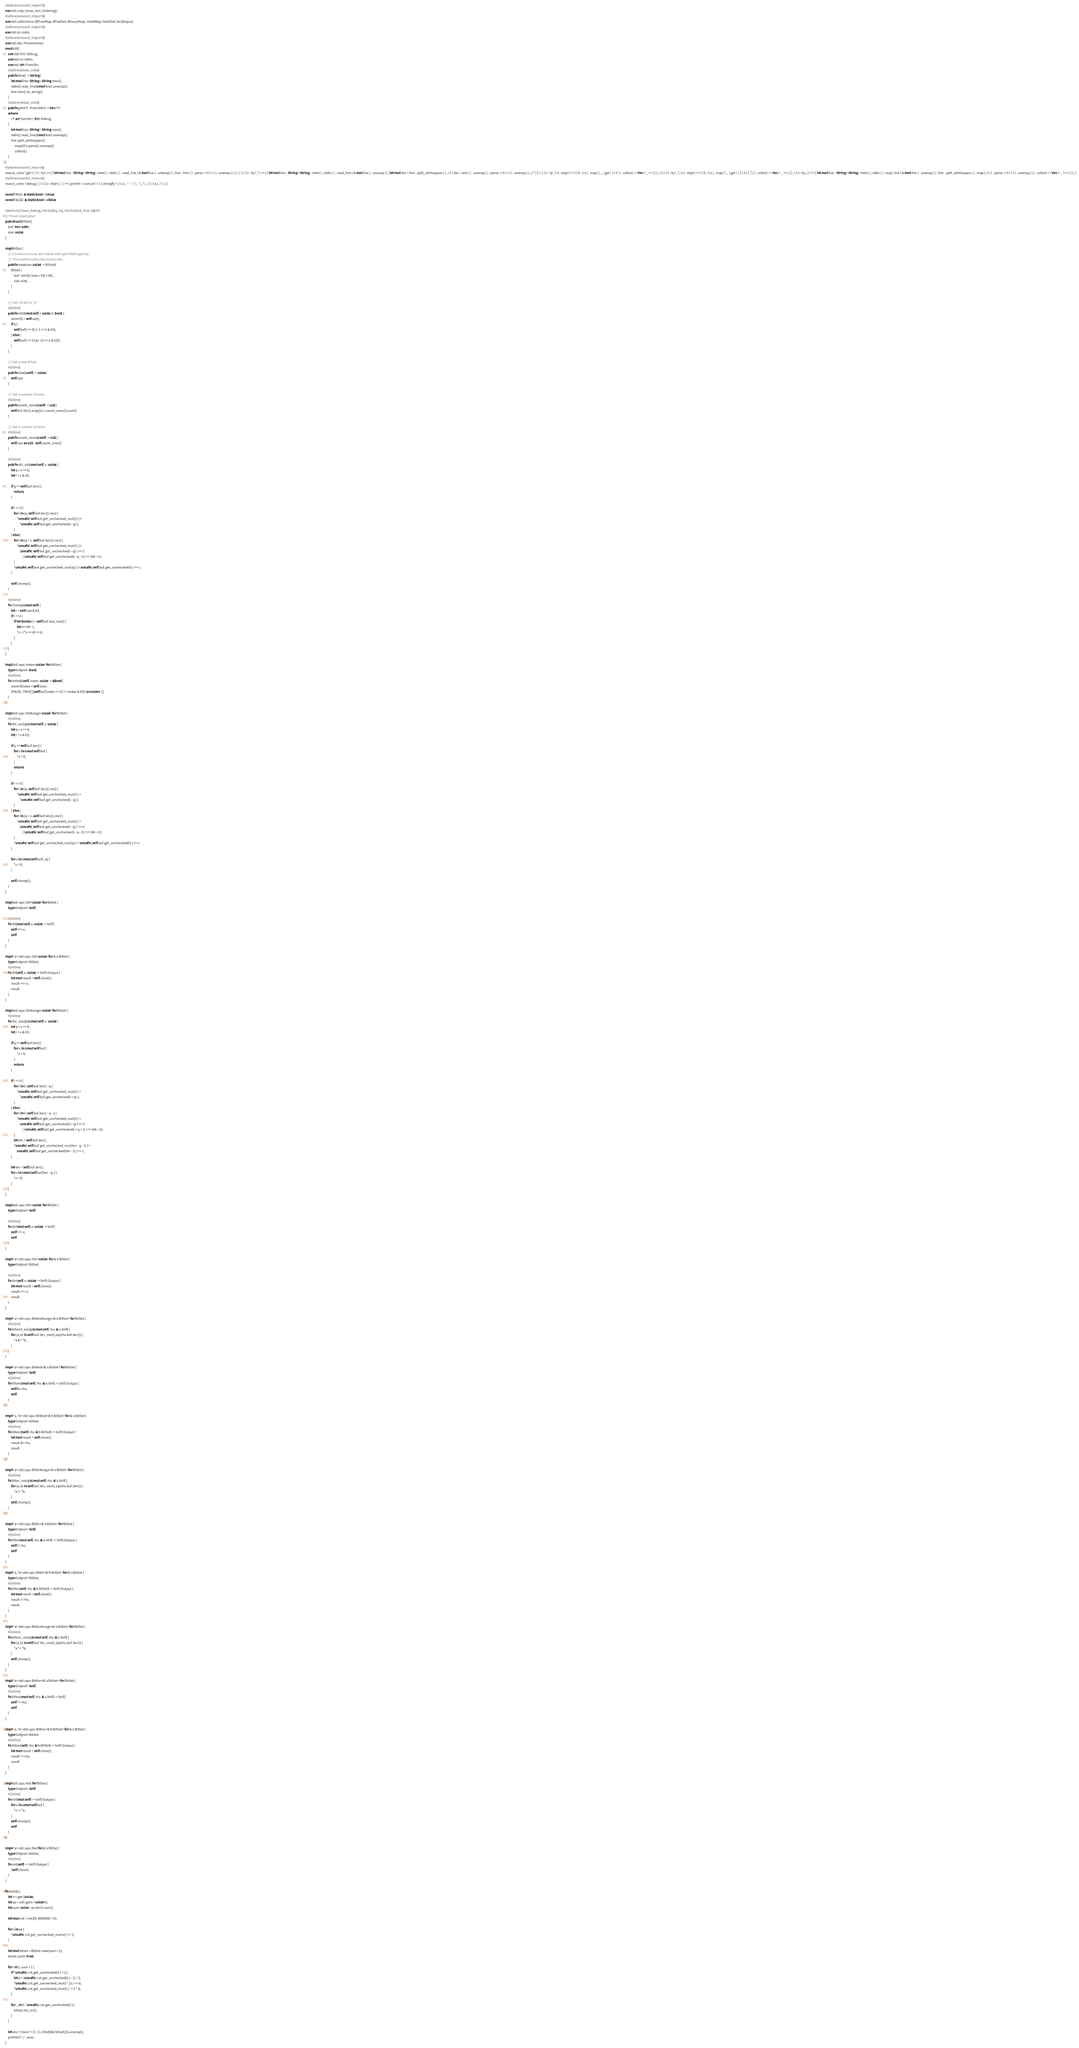Convert code to text. <code><loc_0><loc_0><loc_500><loc_500><_Rust_>#[allow(unused_imports)]
use std::cmp::{max, min, Ordering};
#[allow(unused_imports)]
use std::collections::{BTreeMap, BTreeSet, BinaryHeap, HashMap, HashSet, VecDeque};
#[allow(unused_imports)]
use std::io::stdin;
#[allow(unused_imports)]
use std::iter::FromIterator;
mod util {
    use std::fmt::Debug;
    use std::io::stdin;
    use std::str::FromStr;
    #[allow(dead_code)]
    pub fn line() -> String {
        let mut line: String = String::new();
        stdin().read_line(&mut line).unwrap();
        line.trim().to_string()
    }
    #[allow(dead_code)]
    pub fn gets<T: FromStr>() -> Vec<T>
    where
        <T as FromStr>::Err: Debug,
    {
        let mut line: String = String::new();
        stdin().read_line(&mut line).unwrap();
        line.split_whitespace()
            .map(|t| t.parse().unwrap())
            .collect()
    }
}
#[allow(unused_macros)]
macro_rules ! get { ( $ t : ty ) => { { let mut line : String = String :: new ( ) ; stdin ( ) . read_line ( & mut line ) . unwrap ( ) ; line . trim ( ) . parse ::<$ t > ( ) . unwrap ( ) } } ; ( $ ( $ t : ty ) ,* ) => { { let mut line : String = String :: new ( ) ; stdin ( ) . read_line ( & mut line ) . unwrap ( ) ; let mut iter = line . split_whitespace ( ) ; ( $ ( iter . next ( ) . unwrap ( ) . parse ::<$ t > ( ) . unwrap ( ) , ) * ) } } ; ( $ t : ty ; $ n : expr ) => { ( 0 ..$ n ) . map ( | _ | get ! ( $ t ) ) . collect ::< Vec < _ >> ( ) } ; ( $ ( $ t : ty ) ,*; $ n : expr ) => { ( 0 ..$ n ) . map ( | _ | get ! ( $ ( $ t ) ,* ) ) . collect ::< Vec < _ >> ( ) } ; ( $ t : ty ;; ) => { { let mut line : String = String :: new ( ) ; stdin ( ) . read_line ( & mut line ) . unwrap ( ) ; line . split_whitespace ( ) . map ( | t | t . parse ::<$ t > ( ) . unwrap ( ) ) . collect ::< Vec < _ >> ( ) } } ; }
#[allow(unused_macros)]
macro_rules ! debug { ( $ ( $ a : expr ) ,* ) => { println ! ( concat ! ( $ ( stringify ! ( $ a ) , " = {:?}, " ) ,* ) , $ ( $ a ) ,* ) ; } }

const TRUE: &'static bool = &true;
const FALSE: &'static bool = &false;

#[derive(Clone, Debug, PartialEq, Eq, PartialOrd, Ord, Hash)]
/// Fixed sized bitset
pub struct BitSet {
    buf: Vec<u64>,
    size: usize,
}

impl BitSet {
    /// Construct a new, zero bitset with specified capacity.
    /// This method allocates O(size) bits
    pub fn new(size: usize) -> BitSet {
        BitSet {
            buf: vec![0; (size + 63) / 64],
            size: size,
        }
    }

    /// Set i-th bit to `b`
    #[inline]
    pub fn set(&mut self, i: usize, b: bool) {
        assert!(i < self.size);
        if b {
            self.buf[i >> 6] |= 1 << (i & 63);
        } else {
            self.buf[i >> 6] &= !(1 << (i & 63));
        }
    }

    /// Get a size of bits
    #[inline]
    pub fn size(&self) -> usize {
        self.size
    }

    /// Get a number of ones
    #[inline]
    pub fn count_ones(&self) -> u32 {
        self.buf.iter().map(|x| x.count_ones()).sum()
    }

    /// Get a number of zeros
    #[inline]
    pub fn count_zeros(&self) -> u32 {
        self.size as u32 - self.count_ones()
    }

    #[inline]
    pub fn shl_or(&mut self, x: usize) {
        let q = x >> 6;
        let r = x & 63;

        if q >= self.buf.len() {
            return;
        }

        if r == 0 {
            for i in (q..self.buf.len()).rev() {
                *unsafe { self.buf.get_unchecked_mut(i) } |=
                    *unsafe { self.buf.get_unchecked(i - q) };
            }
        } else {
            for i in (q + 1..self.buf.len()).rev() {
                *unsafe { self.buf.get_unchecked_mut(i) } |=
                    (unsafe { self.buf.get_unchecked(i - q) } << r)
                        | (unsafe { self.buf.get_unchecked(i - q - 1) } >> (64 - r));
            }
            *unsafe { self.buf.get_unchecked_mut(q) } |= unsafe { self.buf.get_unchecked(0) } << r;
        }

        self.chomp();
    }

    #[inline]
    fn chomp(&mut self) {
        let r = self.size & 63;
        if r != 0 {
            if let Some(x) = self.buf.last_mut() {
                let d = 64 - r;
                *x = (*x << d) >> d;
            }
        }
    }
}

impl std::ops::Index<usize> for BitSet {
    type Output = bool;
    #[inline]
    fn index(&self, index: usize) -> &bool {
        assert!(index < self.size);
        [FALSE, TRUE][(self.buf[index >> 6] >> (index & 63)) as usize & 1]
    }
}

impl std::ops::ShlAssign<usize> for BitSet {
    #[inline]
    fn shl_assign(&mut self, x: usize) {
        let q = x >> 6;
        let r = x & 63;

        if q >= self.buf.len() {
            for x in &mut self.buf {
                *x = 0;
            }
            return;
        }

        if r == 0 {
            for i in (q..self.buf.len()).rev() {
                *unsafe { self.buf.get_unchecked_mut(i) } =
                    *unsafe { self.buf.get_unchecked(i - q) };
            }
        } else {
            for i in (q + 1..self.buf.len()).rev() {
                *unsafe { self.buf.get_unchecked_mut(i) } =
                    (unsafe { self.buf.get_unchecked(i - q) } << r)
                        | (unsafe { self.buf.get_unchecked(i - q - 1) } >> (64 - r));
            }
            *unsafe { self.buf.get_unchecked_mut(q) } = unsafe { self.buf.get_unchecked(0) } << r;
        }

        for x in &mut self.buf[..q] {
            *x = 0;
        }

        self.chomp();
    }
}

impl std::ops::Shl<usize> for BitSet {
    type Output = Self;

    #[inline]
    fn shl(mut self, x: usize) -> Self {
        self <<= x;
        self
    }
}

impl<'a> std::ops::Shl<usize> for &'a BitSet {
    type Output = BitSet;
    #[inline]
    fn shl(self, x: usize) -> Self::Output {
        let mut result = self.clone();
        result <<= x;
        result
    }
}

impl std::ops::ShrAssign<usize> for BitSet {
    #[inline]
    fn shr_assign(&mut self, x: usize) {
        let q = x >> 6;
        let r = x & 63;

        if q >= self.buf.len() {
            for x in &mut self.buf {
                *x = 0;
            }
            return;
        }

        if r == 0 {
            for i in 0..self.buf.len() - q {
                *unsafe { self.buf.get_unchecked_mut(i) } =
                    *unsafe { self.buf.get_unchecked(i + q) };
            }
        } else {
            for i in 0..self.buf.len() - q - 1 {
                *unsafe { self.buf.get_unchecked_mut(i) } =
                    (unsafe { self.buf.get_unchecked(i + q) } >> r)
                        | (unsafe { self.buf.get_unchecked(i + q + 1) } << (64 - r));
            }
            let len = self.buf.len();
            *unsafe { self.buf.get_unchecked_mut(len - q - 1) } =
                unsafe { self.buf.get_unchecked(len - 1) } >> r;
        }

        let len = self.buf.len();
        for x in &mut self.buf[len - q..] {
            *x = 0;
        }
    }
}

impl std::ops::Shr<usize> for BitSet {
    type Output = Self;

    #[inline]
    fn shr(mut self, x: usize) -> Self {
        self >>= x;
        self
    }
}

impl<'a> std::ops::Shr<usize> for &'a BitSet {
    type Output = BitSet;

    #[inline]
    fn shr(self, x: usize) -> Self::Output {
        let mut result = self.clone();
        result >>= x;
        result
    }
}

impl<'a> std::ops::BitAndAssign<&'a BitSet> for BitSet {
    #[inline]
    fn bitand_assign(&mut self, rhs: &'a Self) {
        for (a, b) in self.buf.iter_mut().zip(rhs.buf.iter()) {
            *a &= *b;
        }
    }
}

impl<'a> std::ops::BitAnd<&'a BitSet> for BitSet {
    type Output = Self;
    #[inline]
    fn bitand(mut self, rhs: &'a Self) -> Self::Output {
        self &= rhs;
        self
    }
}

impl<'a, 'b> std::ops::BitAnd<&'b BitSet> for &'a BitSet {
    type Output = BitSet;
    #[inline]
    fn bitand(self, rhs: &'b BitSet) -> Self::Output {
        let mut result = self.clone();
        result &= rhs;
        result
    }
}

impl<'a> std::ops::BitOrAssign<&'a BitSet> for BitSet {
    #[inline]
    fn bitor_assign(&mut self, rhs: &'a Self) {
        for (a, b) in self.buf.iter_mut().zip(rhs.buf.iter()) {
            *a |= *b;
        }
        self.chomp();
    }
}

impl<'a> std::ops::BitOr<&'a BitSet> for BitSet {
    type Output = Self;
    #[inline]
    fn bitor(mut self, rhs: &'a Self) -> Self::Output {
        self |= rhs;
        self
    }
}

impl<'a, 'b> std::ops::BitOr<&'b BitSet> for &'a BitSet {
    type Output = BitSet;
    #[inline]
    fn bitor(self, rhs: &'b BitSet) -> Self::Output {
        let mut result = self.clone();
        result |= rhs;
        result
    }
}

impl<'a> std::ops::BitXorAssign<&'a BitSet> for BitSet {
    #[inline]
    fn bitxor_assign(&mut self, rhs: &'a Self) {
        for (a, b) in self.buf.iter_mut().zip(rhs.buf.iter()) {
            *a ^= *b;
        }
        self.chomp();
    }
}

impl<'a> std::ops::BitXor<&'a BitSet> for BitSet {
    type Output = Self;
    #[inline]
    fn bitxor(mut self, rhs: &'a Self) -> Self {
        self ^= rhs;
        self
    }
}

impl<'a, 'b> std::ops::BitXor<&'b BitSet> for &'a BitSet {
    type Output = BitSet;
    #[inline]
    fn bitxor(self, rhs: &'b BitSet) -> Self::Output {
        let mut result = self.clone();
        result ^= rhs;
        result
    }
}

impl std::ops::Not for BitSet {
    type Output = Self;
    #[inline]
    fn not(mut self) -> Self::Output {
        for x in &mut self.buf {
            *x = !*x;
        }
        self.chomp();
        self
    }
}

impl<'a> std::ops::Not for &'a BitSet {
    type Output = BitSet;
    #[inline]
    fn not(self) -> Self::Output {
        !self.clone()
    }
}

fn main() {
    let n = get!(usize);
    let aa = util::gets::<usize>();
    let sum: usize = aa.iter().sum();

    let mut cnt = vec![0; 4000000 + 5];

    for a in aa {
        *unsafe { cnt.get_unchecked_mut(a) } += 1;
    }

    let mut bitset = BitSet::new(sum + 1);
    bitset.set(0, true);

    for i in 1..sum + 1 {
        if *unsafe { cnt.get_unchecked(i) } > 2 {
            let d = (unsafe { cnt.get_unchecked(i) } - 1) / 2;
            *unsafe { cnt.get_unchecked_mut(i * 2) } += d;
            *unsafe { cnt.get_unchecked_mut(i) } -= 2 * d;
        }

        for _ in 0..*unsafe { cnt.get_unchecked(i) } {
            bitset.shl_or(i);
        }
    }

    let ans = ((sum + 1) / 2..).find(|&i| bitset[i]).unwrap();
    println!("{}", ans);
}
</code> 